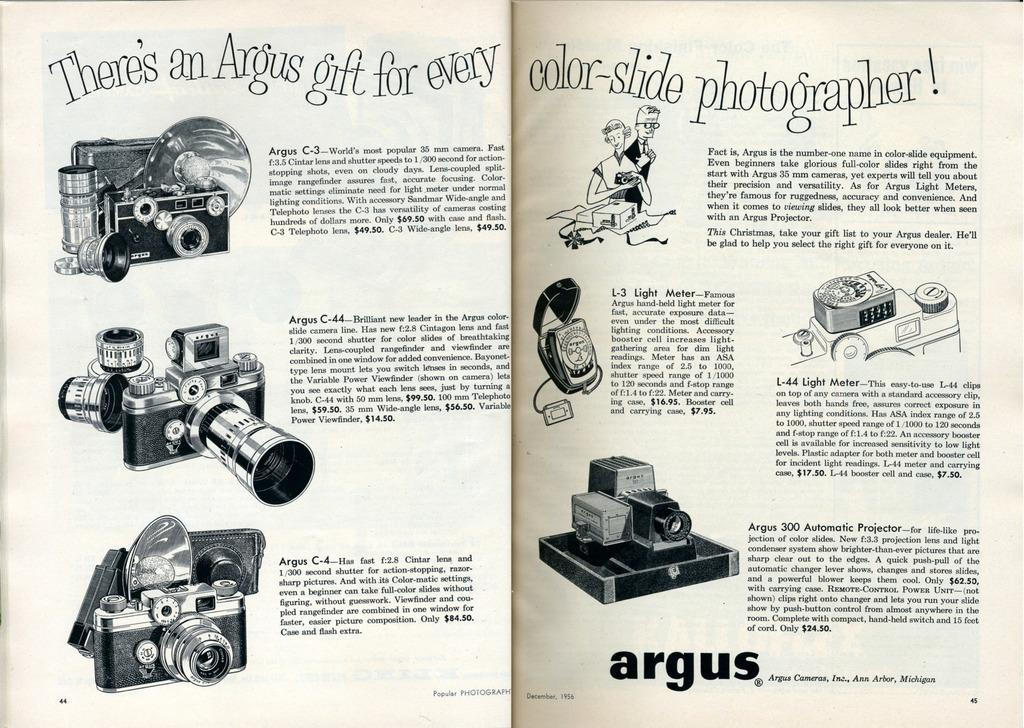What type of resource is the image from? The image is from a textbook. What can be seen on the papers in the image? There is text written on papers in the image. What type of equipment is depicted in the image? There are pictures of cameras and camcorders in the image. What type of train can be seen on the edge of the jar in the image? There is no train or jar present in the image; it features textbook content related to cameras and camcorders. 